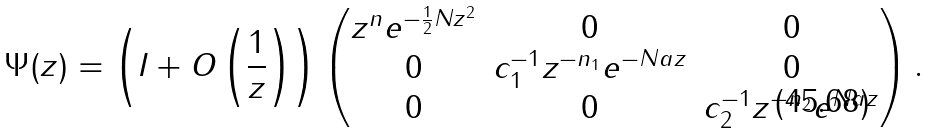<formula> <loc_0><loc_0><loc_500><loc_500>\Psi ( z ) = \left ( I + O \left ( \frac { 1 } { z } \right ) \right ) \begin{pmatrix} z ^ { n } e ^ { - \frac { 1 } { 2 } N z ^ { 2 } } & 0 & 0 \\ 0 & c _ { 1 } ^ { - 1 } z ^ { - n _ { 1 } } e ^ { - N a z } & 0 \\ 0 & 0 & c _ { 2 } ^ { - 1 } z ^ { - n _ { 2 } } e ^ { N a z } \end{pmatrix} .</formula> 